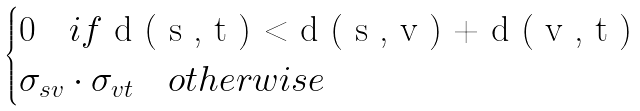<formula> <loc_0><loc_0><loc_500><loc_500>\begin{cases} 0 \quad i f $ d ( s , t ) < d ( s , v ) + d ( v , t ) $ \\ \sigma _ { s v } \cdot \sigma _ { v t } \quad o t h e r w i s e \end{cases}</formula> 